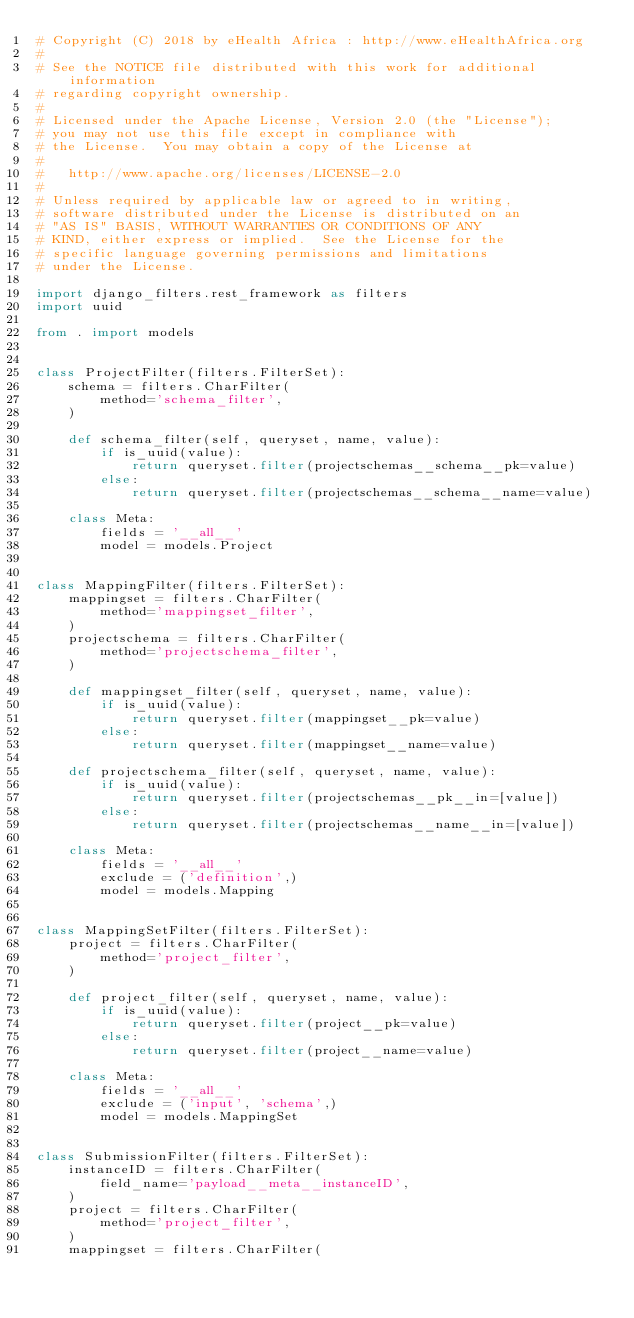<code> <loc_0><loc_0><loc_500><loc_500><_Python_># Copyright (C) 2018 by eHealth Africa : http://www.eHealthAfrica.org
#
# See the NOTICE file distributed with this work for additional information
# regarding copyright ownership.
#
# Licensed under the Apache License, Version 2.0 (the "License");
# you may not use this file except in compliance with
# the License.  You may obtain a copy of the License at
#
#   http://www.apache.org/licenses/LICENSE-2.0
#
# Unless required by applicable law or agreed to in writing,
# software distributed under the License is distributed on an
# "AS IS" BASIS, WITHOUT WARRANTIES OR CONDITIONS OF ANY
# KIND, either express or implied.  See the License for the
# specific language governing permissions and limitations
# under the License.

import django_filters.rest_framework as filters
import uuid

from . import models


class ProjectFilter(filters.FilterSet):
    schema = filters.CharFilter(
        method='schema_filter',
    )

    def schema_filter(self, queryset, name, value):
        if is_uuid(value):
            return queryset.filter(projectschemas__schema__pk=value)
        else:
            return queryset.filter(projectschemas__schema__name=value)

    class Meta:
        fields = '__all__'
        model = models.Project


class MappingFilter(filters.FilterSet):
    mappingset = filters.CharFilter(
        method='mappingset_filter',
    )
    projectschema = filters.CharFilter(
        method='projectschema_filter',
    )

    def mappingset_filter(self, queryset, name, value):
        if is_uuid(value):
            return queryset.filter(mappingset__pk=value)
        else:
            return queryset.filter(mappingset__name=value)

    def projectschema_filter(self, queryset, name, value):
        if is_uuid(value):
            return queryset.filter(projectschemas__pk__in=[value])
        else:
            return queryset.filter(projectschemas__name__in=[value])

    class Meta:
        fields = '__all__'
        exclude = ('definition',)
        model = models.Mapping


class MappingSetFilter(filters.FilterSet):
    project = filters.CharFilter(
        method='project_filter',
    )

    def project_filter(self, queryset, name, value):
        if is_uuid(value):
            return queryset.filter(project__pk=value)
        else:
            return queryset.filter(project__name=value)

    class Meta:
        fields = '__all__'
        exclude = ('input', 'schema',)
        model = models.MappingSet


class SubmissionFilter(filters.FilterSet):
    instanceID = filters.CharFilter(
        field_name='payload__meta__instanceID',
    )
    project = filters.CharFilter(
        method='project_filter',
    )
    mappingset = filters.CharFilter(</code> 